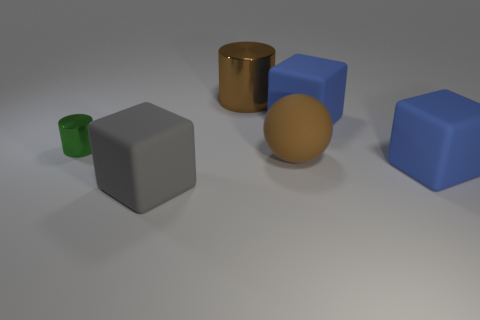What size is the metal thing that is the same color as the big rubber ball?
Ensure brevity in your answer.  Large. How many other things are there of the same color as the big ball?
Offer a very short reply. 1. Are there any large rubber cubes that are to the left of the rubber cube that is behind the brown thing that is in front of the small object?
Offer a very short reply. Yes. What number of metal things are blue blocks or brown cylinders?
Provide a succinct answer. 1. Do the small metallic cylinder and the sphere have the same color?
Your answer should be compact. No. How many large rubber cubes are on the right side of the big cylinder?
Offer a very short reply. 2. What number of large rubber cubes are both in front of the tiny green shiny object and right of the large cylinder?
Provide a succinct answer. 1. The brown object that is made of the same material as the gray block is what shape?
Your answer should be compact. Sphere. There is a cylinder in front of the brown metallic cylinder; is its size the same as the blue cube that is in front of the brown matte object?
Provide a succinct answer. No. There is a tiny cylinder that is on the left side of the large brown metal thing; what is its color?
Make the answer very short. Green. 